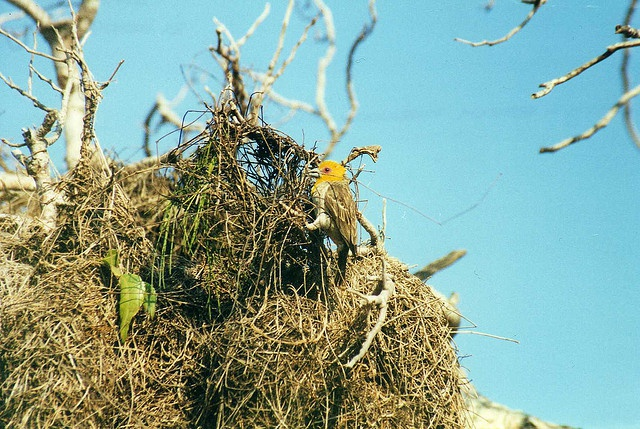Describe the objects in this image and their specific colors. I can see bird in lightblue, tan, khaki, and olive tones and bird in lightblue, olive, and khaki tones in this image. 